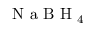Convert formula to latex. <formula><loc_0><loc_0><loc_500><loc_500>N a B H _ { 4 }</formula> 